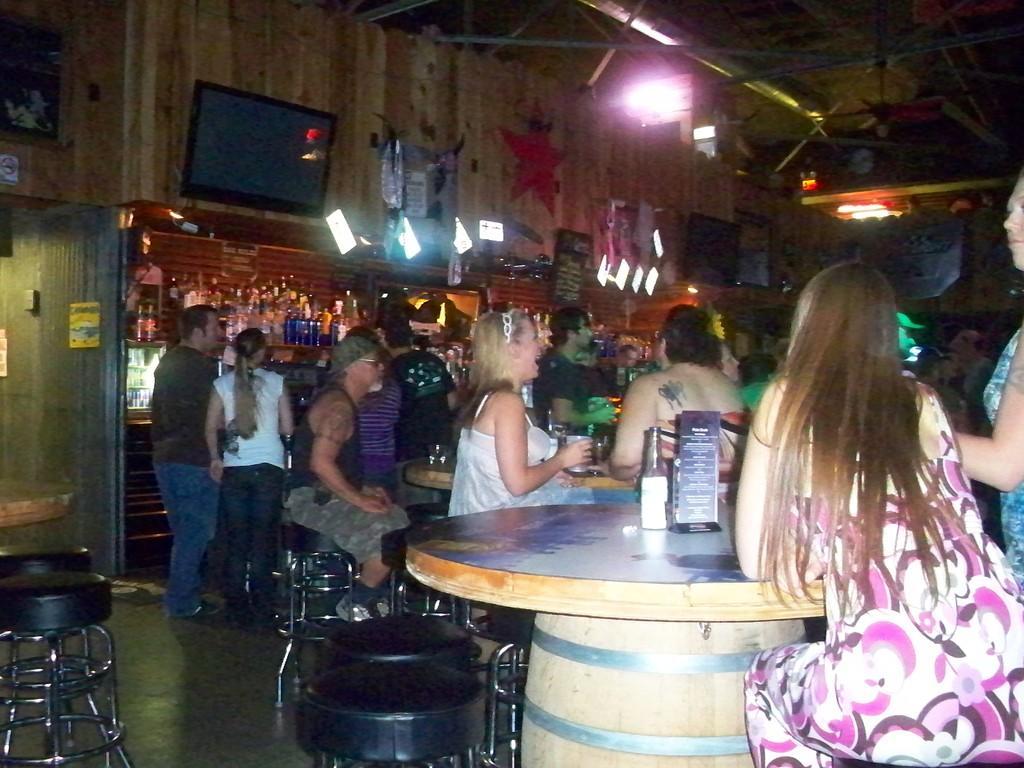Please provide a concise description of this image. In this image I can see a group of people siting on the chair. few people are standing. In front of the woman there is a table on the table there is bottle and a board. At the back side i can see a wine bottles in the rack. There is a television on the wooden wall. On the top there is light. 